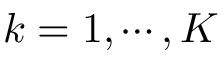<formula> <loc_0><loc_0><loc_500><loc_500>k = 1 , \cdots , K</formula> 